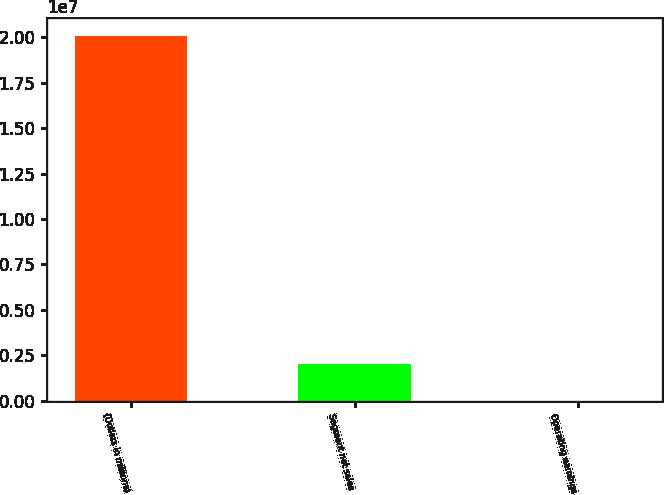Convert chart. <chart><loc_0><loc_0><loc_500><loc_500><bar_chart><fcel>(Dollars in millions)<fcel>Segment net sales<fcel>Operating earnings<nl><fcel>2.0072e+07<fcel>2.00722e+06<fcel>27<nl></chart> 